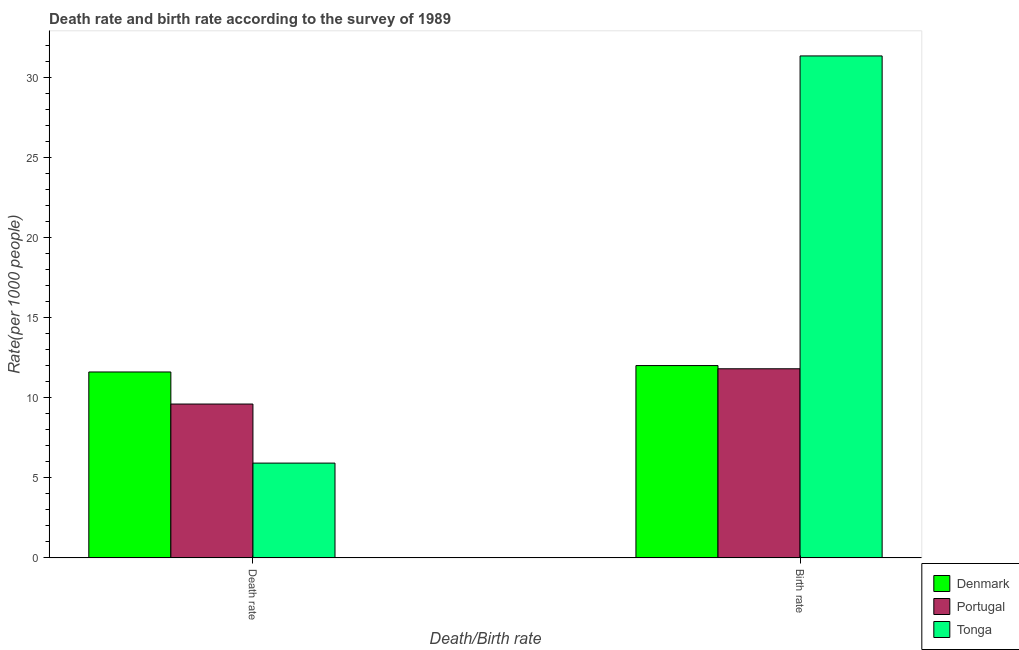How many different coloured bars are there?
Provide a short and direct response. 3. How many groups of bars are there?
Ensure brevity in your answer.  2. Are the number of bars on each tick of the X-axis equal?
Your response must be concise. Yes. How many bars are there on the 1st tick from the left?
Ensure brevity in your answer.  3. How many bars are there on the 1st tick from the right?
Provide a succinct answer. 3. What is the label of the 1st group of bars from the left?
Make the answer very short. Death rate. What is the death rate in Denmark?
Your response must be concise. 11.6. Across all countries, what is the maximum birth rate?
Keep it short and to the point. 31.32. Across all countries, what is the minimum death rate?
Your answer should be compact. 5.92. In which country was the death rate maximum?
Make the answer very short. Denmark. In which country was the birth rate minimum?
Make the answer very short. Portugal. What is the total birth rate in the graph?
Provide a short and direct response. 55.12. What is the difference between the birth rate in Portugal and that in Denmark?
Ensure brevity in your answer.  -0.2. What is the difference between the birth rate in Portugal and the death rate in Denmark?
Your response must be concise. 0.2. What is the average birth rate per country?
Provide a short and direct response. 18.37. What is the difference between the death rate and birth rate in Denmark?
Make the answer very short. -0.4. What is the ratio of the birth rate in Portugal to that in Denmark?
Your answer should be very brief. 0.98. Is the birth rate in Portugal less than that in Denmark?
Provide a succinct answer. Yes. How many countries are there in the graph?
Keep it short and to the point. 3. Are the values on the major ticks of Y-axis written in scientific E-notation?
Make the answer very short. No. What is the title of the graph?
Give a very brief answer. Death rate and birth rate according to the survey of 1989. What is the label or title of the X-axis?
Your response must be concise. Death/Birth rate. What is the label or title of the Y-axis?
Give a very brief answer. Rate(per 1000 people). What is the Rate(per 1000 people) in Denmark in Death rate?
Give a very brief answer. 11.6. What is the Rate(per 1000 people) of Portugal in Death rate?
Provide a short and direct response. 9.6. What is the Rate(per 1000 people) of Tonga in Death rate?
Ensure brevity in your answer.  5.92. What is the Rate(per 1000 people) of Tonga in Birth rate?
Your answer should be compact. 31.32. Across all Death/Birth rate, what is the maximum Rate(per 1000 people) of Denmark?
Provide a short and direct response. 12. Across all Death/Birth rate, what is the maximum Rate(per 1000 people) of Portugal?
Keep it short and to the point. 11.8. Across all Death/Birth rate, what is the maximum Rate(per 1000 people) in Tonga?
Keep it short and to the point. 31.32. Across all Death/Birth rate, what is the minimum Rate(per 1000 people) in Denmark?
Offer a very short reply. 11.6. Across all Death/Birth rate, what is the minimum Rate(per 1000 people) in Portugal?
Provide a short and direct response. 9.6. Across all Death/Birth rate, what is the minimum Rate(per 1000 people) in Tonga?
Make the answer very short. 5.92. What is the total Rate(per 1000 people) in Denmark in the graph?
Give a very brief answer. 23.6. What is the total Rate(per 1000 people) in Portugal in the graph?
Offer a terse response. 21.4. What is the total Rate(per 1000 people) of Tonga in the graph?
Your answer should be compact. 37.23. What is the difference between the Rate(per 1000 people) in Denmark in Death rate and that in Birth rate?
Your answer should be very brief. -0.4. What is the difference between the Rate(per 1000 people) in Tonga in Death rate and that in Birth rate?
Your response must be concise. -25.4. What is the difference between the Rate(per 1000 people) of Denmark in Death rate and the Rate(per 1000 people) of Tonga in Birth rate?
Keep it short and to the point. -19.72. What is the difference between the Rate(per 1000 people) in Portugal in Death rate and the Rate(per 1000 people) in Tonga in Birth rate?
Offer a terse response. -21.72. What is the average Rate(per 1000 people) of Denmark per Death/Birth rate?
Offer a very short reply. 11.8. What is the average Rate(per 1000 people) in Portugal per Death/Birth rate?
Offer a terse response. 10.7. What is the average Rate(per 1000 people) in Tonga per Death/Birth rate?
Provide a succinct answer. 18.62. What is the difference between the Rate(per 1000 people) in Denmark and Rate(per 1000 people) in Tonga in Death rate?
Your answer should be very brief. 5.68. What is the difference between the Rate(per 1000 people) in Portugal and Rate(per 1000 people) in Tonga in Death rate?
Keep it short and to the point. 3.69. What is the difference between the Rate(per 1000 people) of Denmark and Rate(per 1000 people) of Tonga in Birth rate?
Your response must be concise. -19.32. What is the difference between the Rate(per 1000 people) of Portugal and Rate(per 1000 people) of Tonga in Birth rate?
Offer a terse response. -19.52. What is the ratio of the Rate(per 1000 people) in Denmark in Death rate to that in Birth rate?
Offer a very short reply. 0.97. What is the ratio of the Rate(per 1000 people) in Portugal in Death rate to that in Birth rate?
Provide a short and direct response. 0.81. What is the ratio of the Rate(per 1000 people) of Tonga in Death rate to that in Birth rate?
Your answer should be compact. 0.19. What is the difference between the highest and the second highest Rate(per 1000 people) of Portugal?
Give a very brief answer. 2.2. What is the difference between the highest and the second highest Rate(per 1000 people) of Tonga?
Your answer should be very brief. 25.4. What is the difference between the highest and the lowest Rate(per 1000 people) of Portugal?
Provide a short and direct response. 2.2. What is the difference between the highest and the lowest Rate(per 1000 people) of Tonga?
Ensure brevity in your answer.  25.4. 